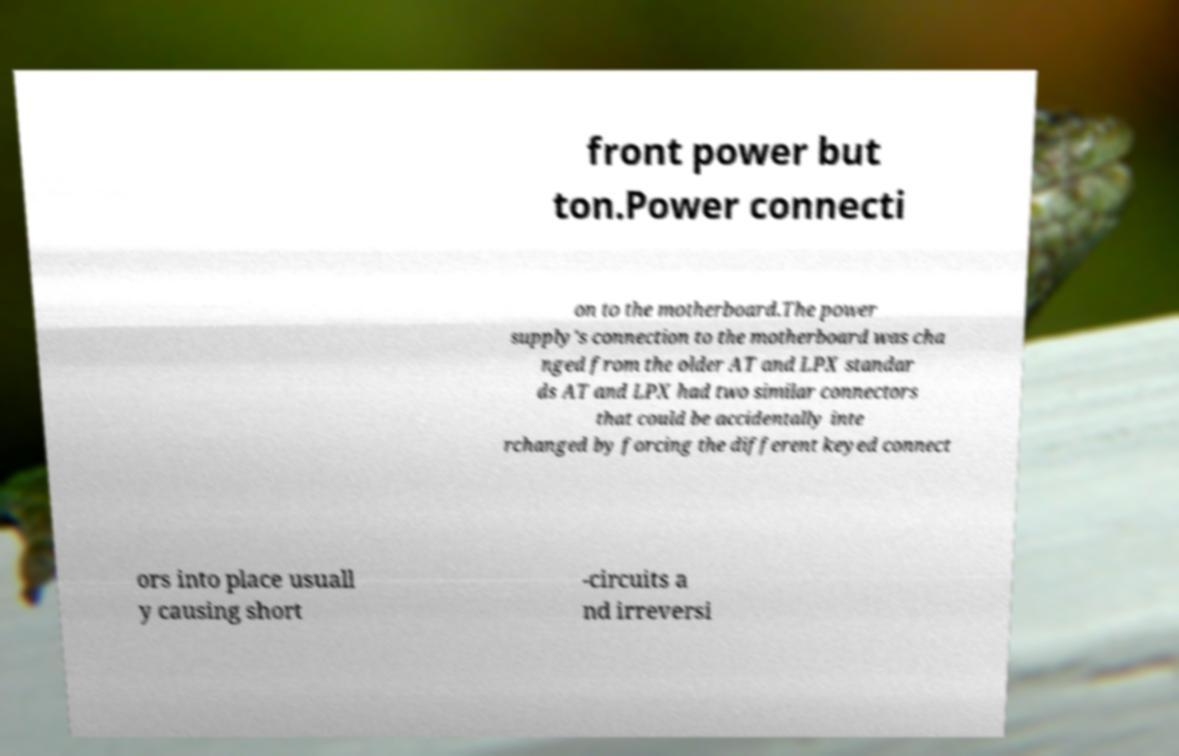Could you extract and type out the text from this image? front power but ton.Power connecti on to the motherboard.The power supply's connection to the motherboard was cha nged from the older AT and LPX standar ds AT and LPX had two similar connectors that could be accidentally inte rchanged by forcing the different keyed connect ors into place usuall y causing short -circuits a nd irreversi 